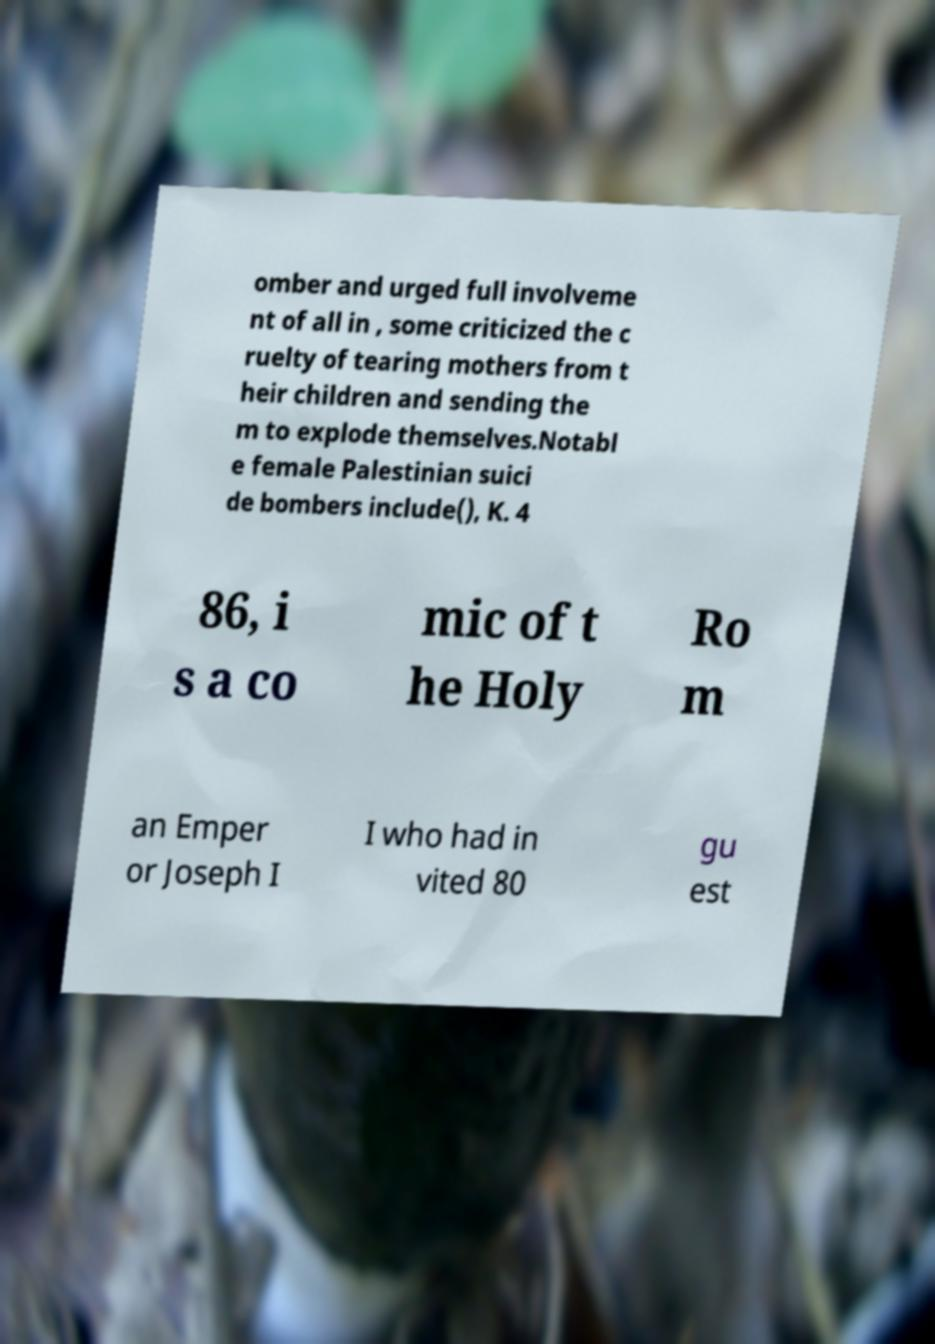Please identify and transcribe the text found in this image. omber and urged full involveme nt of all in , some criticized the c ruelty of tearing mothers from t heir children and sending the m to explode themselves.Notabl e female Palestinian suici de bombers include(), K. 4 86, i s a co mic of t he Holy Ro m an Emper or Joseph I I who had in vited 80 gu est 